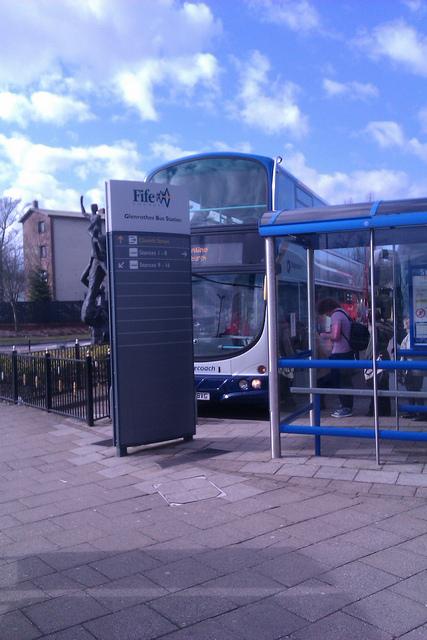What is the flooring made of?
Keep it brief. Brick. What color is the bus stop?
Give a very brief answer. Blue. Is there a guy at the bus stop?
Write a very short answer. Yes. 